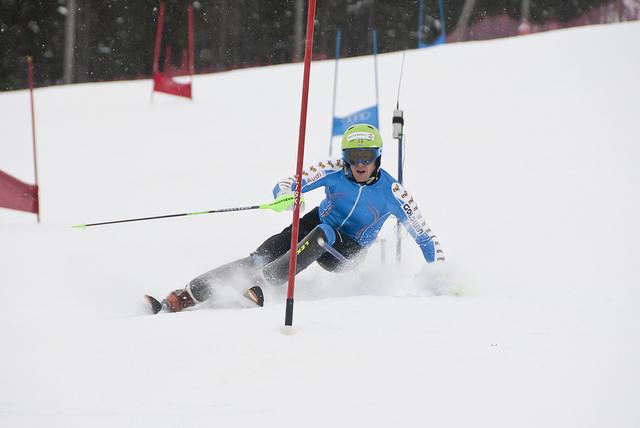What color are the goggles?
Give a very brief answer. Blue. Is this guy a good skier?
Keep it brief. Yes. Is it cold?
Keep it brief. Yes. 